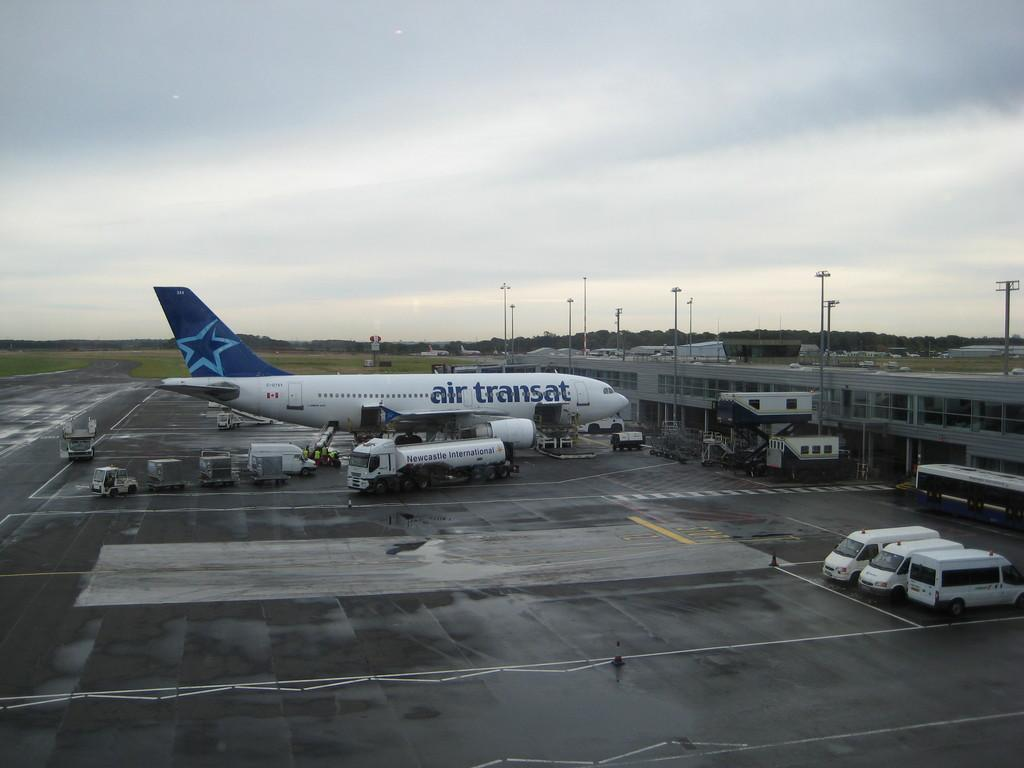<image>
Describe the image concisely. The airplane parked in front of the terminal has the words "air transat" written on it. 